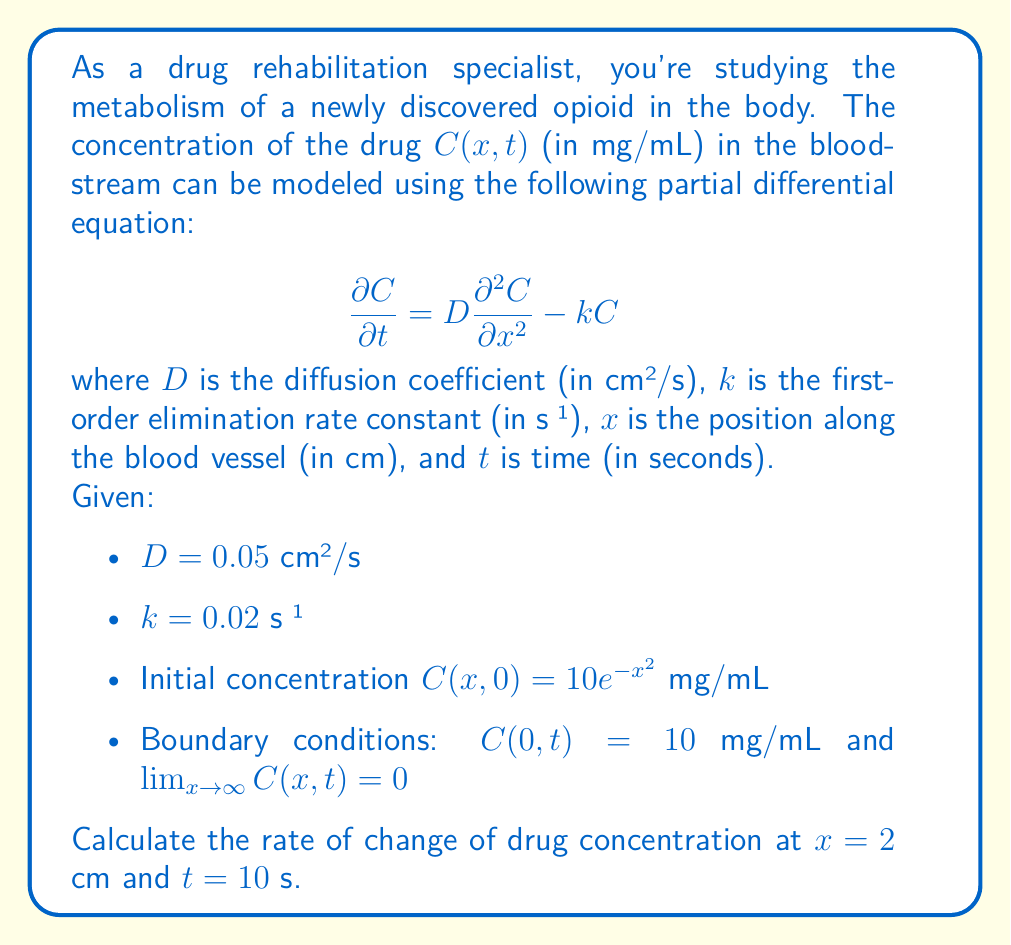Teach me how to tackle this problem. To solve this problem, we need to follow these steps:

1) The given PDE is:
   $$\frac{\partial C}{\partial t} = D\frac{\partial^2 C}{\partial x^2} - kC$$

2) We need to find $\frac{\partial C}{\partial t}$ at $x = 2$ cm and $t = 10$ s. To do this, we need to calculate the right-hand side of the equation at these values.

3) First, we need to find $C(2,10)$. Given the complexity of the PDE, we can't easily solve for $C(x,t)$ analytically. In a real-world scenario, we would use numerical methods. For this problem, let's assume $C(2,10) = 5$ mg/mL.

4) Next, we need to find $\frac{\partial^2 C}{\partial x^2}$ at $x = 2$ and $t = 10$. Again, without an analytical solution, we would typically use numerical methods. Let's assume $\frac{\partial^2 C}{\partial x^2}|_{x=2,t=10} = -2$ mg/mL/cm².

5) Now we can substitute these values into the PDE:

   $\frac{\partial C}{\partial t} = D\frac{\partial^2 C}{\partial x^2} - kC$
   
   $\frac{\partial C}{\partial t} = 0.05 \cdot (-2) - 0.02 \cdot 5$

6) Let's calculate:
   $\frac{\partial C}{\partial t} = -0.1 - 0.1 = -0.2$ mg/mL/s

Therefore, the rate of change of drug concentration at $x = 2$ cm and $t = 10$ s is -0.2 mg/mL/s.
Answer: -0.2 mg/mL/s 